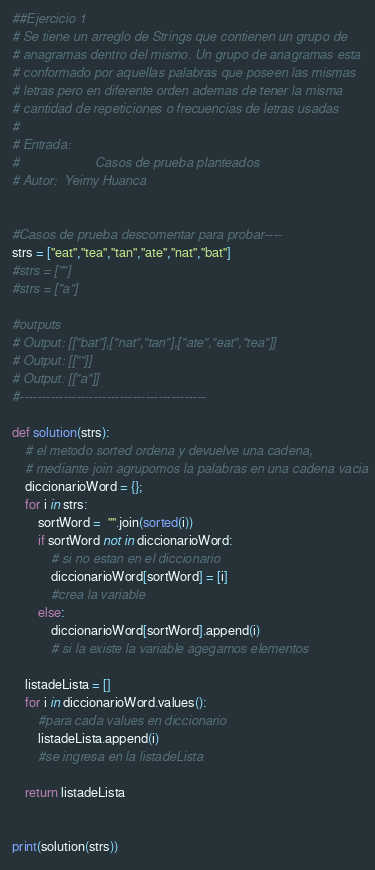<code> <loc_0><loc_0><loc_500><loc_500><_Python_>##Ejercicio 1
# Se tiene un arreglo de Strings que contienen un grupo de
# anagramas dentro del mismo. Un grupo de anagramas esta
# conformado por aquellas palabras que poseen las mismas
# letras pero en diferente orden ademas de tener la misma
# cantidad de repeticiones o frecuencias de letras usadas
# 
# Entrada:
#                     Casos de prueba planteados  
# Autor:  Yeimy Huanca


#Casos de prueba descomentar para probar----
strs = ["eat","tea","tan","ate","nat","bat"]
#strs = [""]
#strs = ["a"]

#outputs
# Output: [["bat"],["nat","tan"],["ate","eat","tea"]]
# Output: [[""]]
# Output: [["a"]]
#-------------------------------------------

def solution(strs):
    # el metodo sorted ordena y devuelve una cadena,
    # mediante join agrupomos la palabras en una cadena vacia
    diccionarioWord = {}; 
    for i in strs:
        sortWord =  "".join(sorted(i))
        if sortWord not in diccionarioWord: 
            # si no estan en el diccionario
            diccionarioWord[sortWord] = [i] 
            #crea la variable
        else:
            diccionarioWord[sortWord].append(i) 
            # si la existe la variable agegamos elementos

    listadeLista = []
    for i in diccionarioWord.values(): 
        #para cada values en diccionario
        listadeLista.append(i) 
        #se ingresa en la listadeLista

    return listadeLista 


print(solution(strs))</code> 